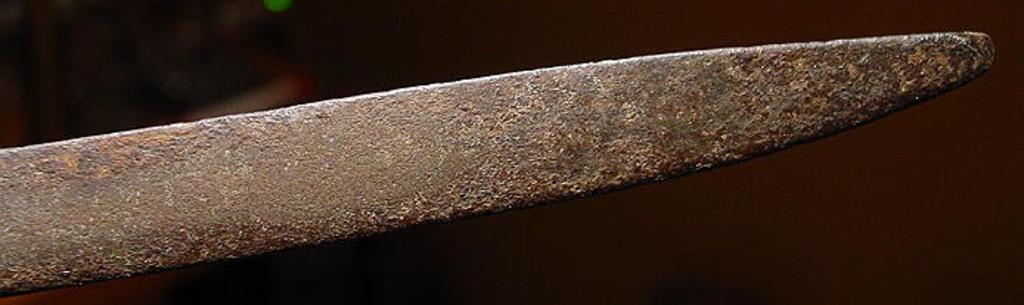What object is the main focus of the image? There is a rusted sword in the image. Can you describe the background of the image? The background of the image is blurred. What type of flower is growing near the rusted sword in the image? There is no flower present in the image; it only features a rusted sword and a blurred background. 